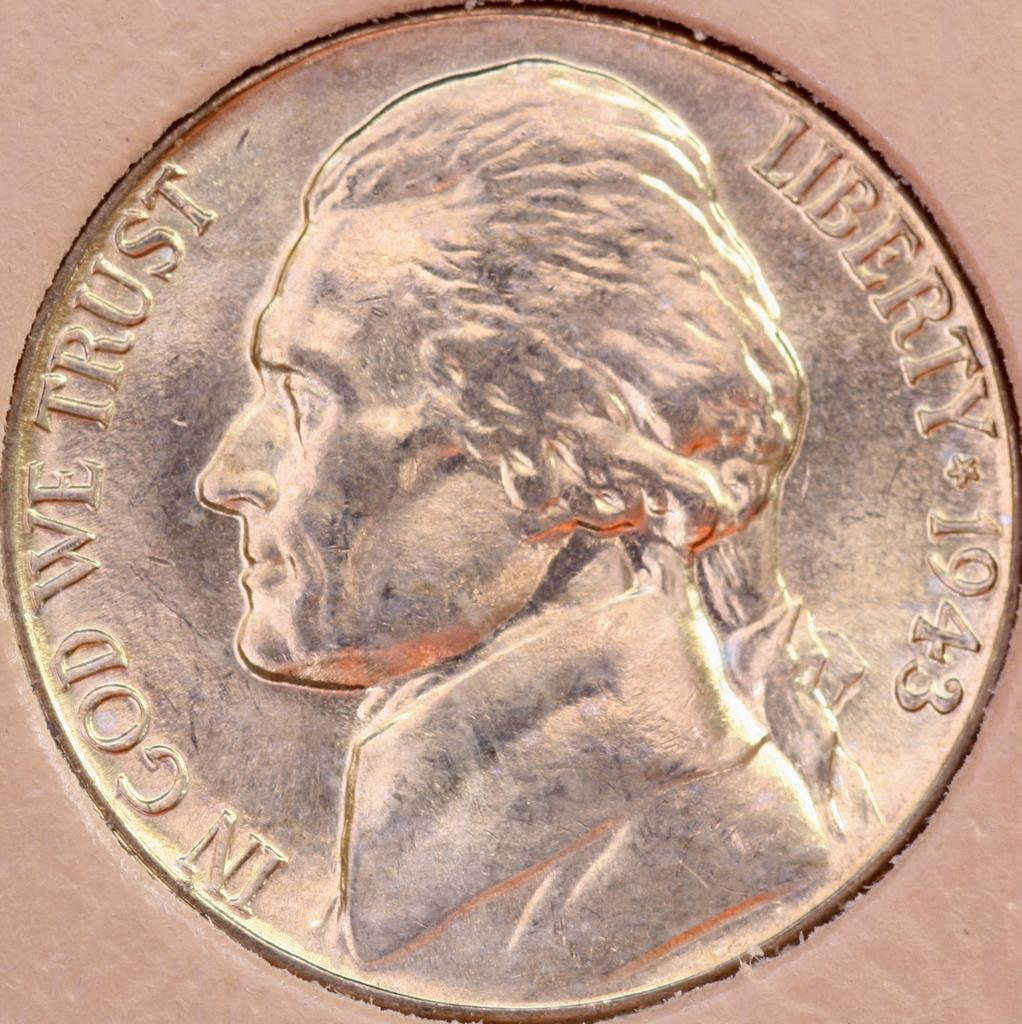<image>
Relay a brief, clear account of the picture shown. A coin from 1943 with the phrase In God We Trust and Liberty. 